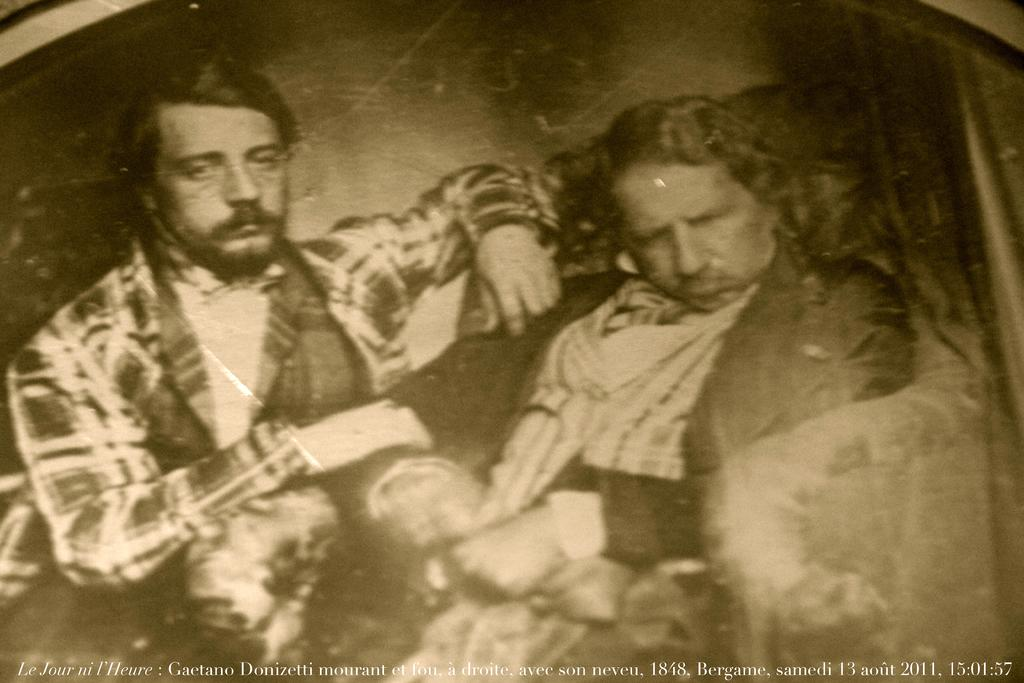What type of visual is the image? The image is a poster. What can be seen in the poster? There are depictions of people in the poster. Is there any text in the poster? Yes, there is some text at the bottom of the poster. What color is the sweater worn by the person in the poster? There is no sweater mentioned or visible in the poster. Can you tell me how many cords are connected to the poster? The provided facts do not mention any cords connected to the poster. Are there any bananas depicted in the poster? There are no bananas depicted in the poster. 